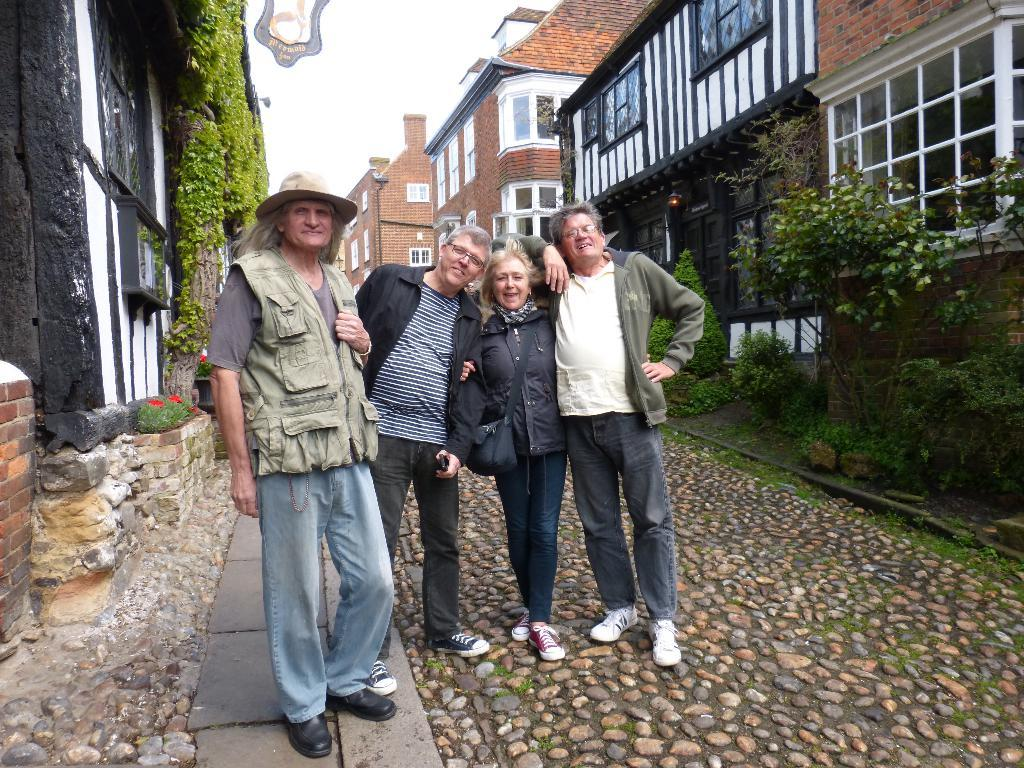How many people are standing on the road in the image? There are four persons standing on the road in the image. What can be seen in the background of the image? In the background of the image, there is grass, trees, a fence, buildings, windows, and the sky. Can you describe the time of day when the image was taken? The image was taken during the day. What type of experience does the doctor have with the bulb in the image? There is no doctor or bulb present in the image. 